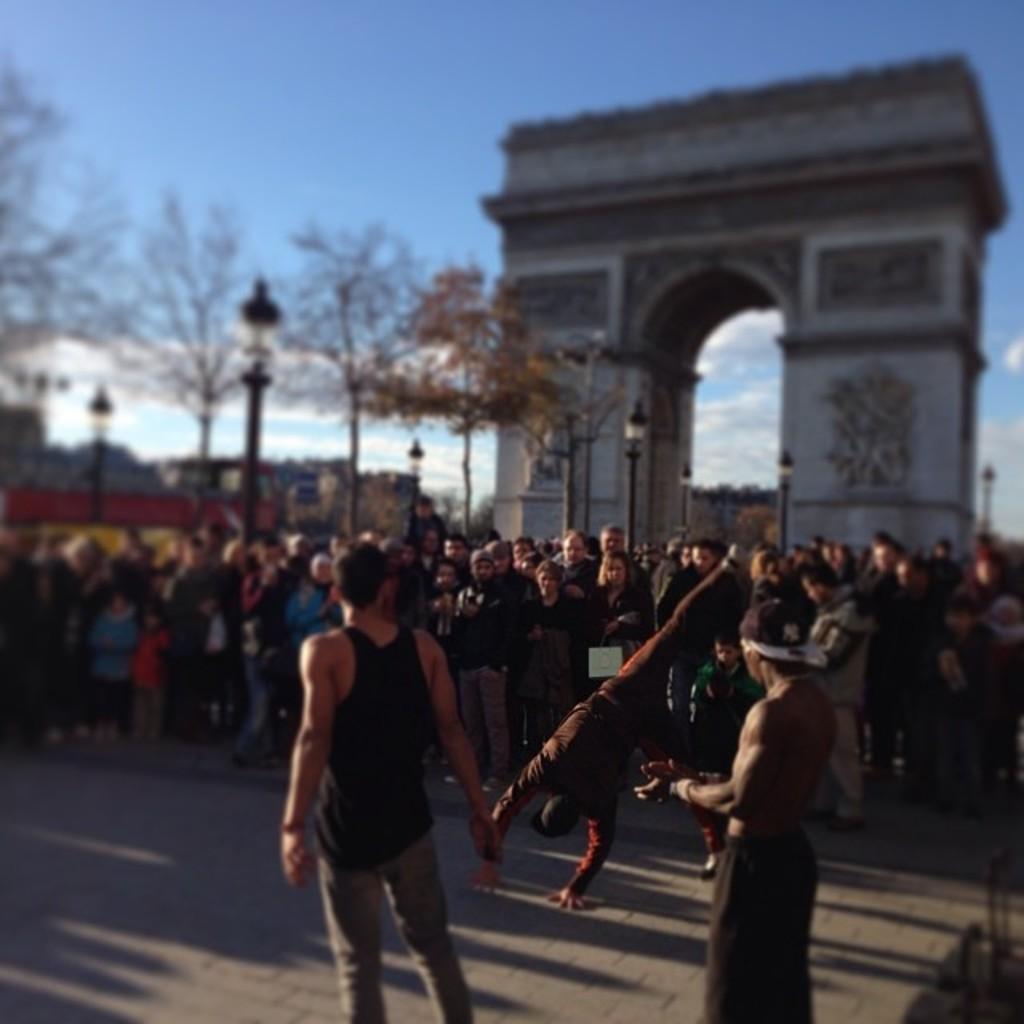Can you describe this image briefly? In this picture I can see number of people standing on the path and in the middle of this picture, I can see few light poles, trees and an arch. In the background I can see the sky and I see that it is blurred. 